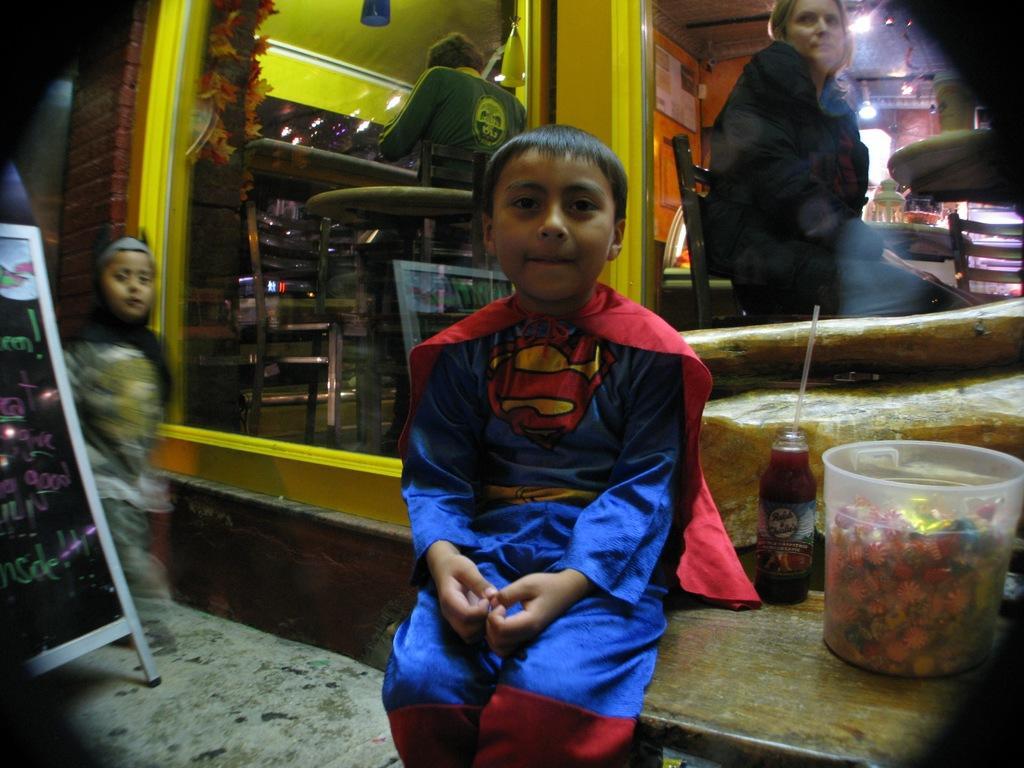Please provide a concise description of this image. In the picture there is a boy sitting on a table and behind him there are some toffees in a box,behind the boy there is a cafe and inside the cafe some people are sitting and outside the cafe there is a cupboard and beside the board there is another kid standing. 